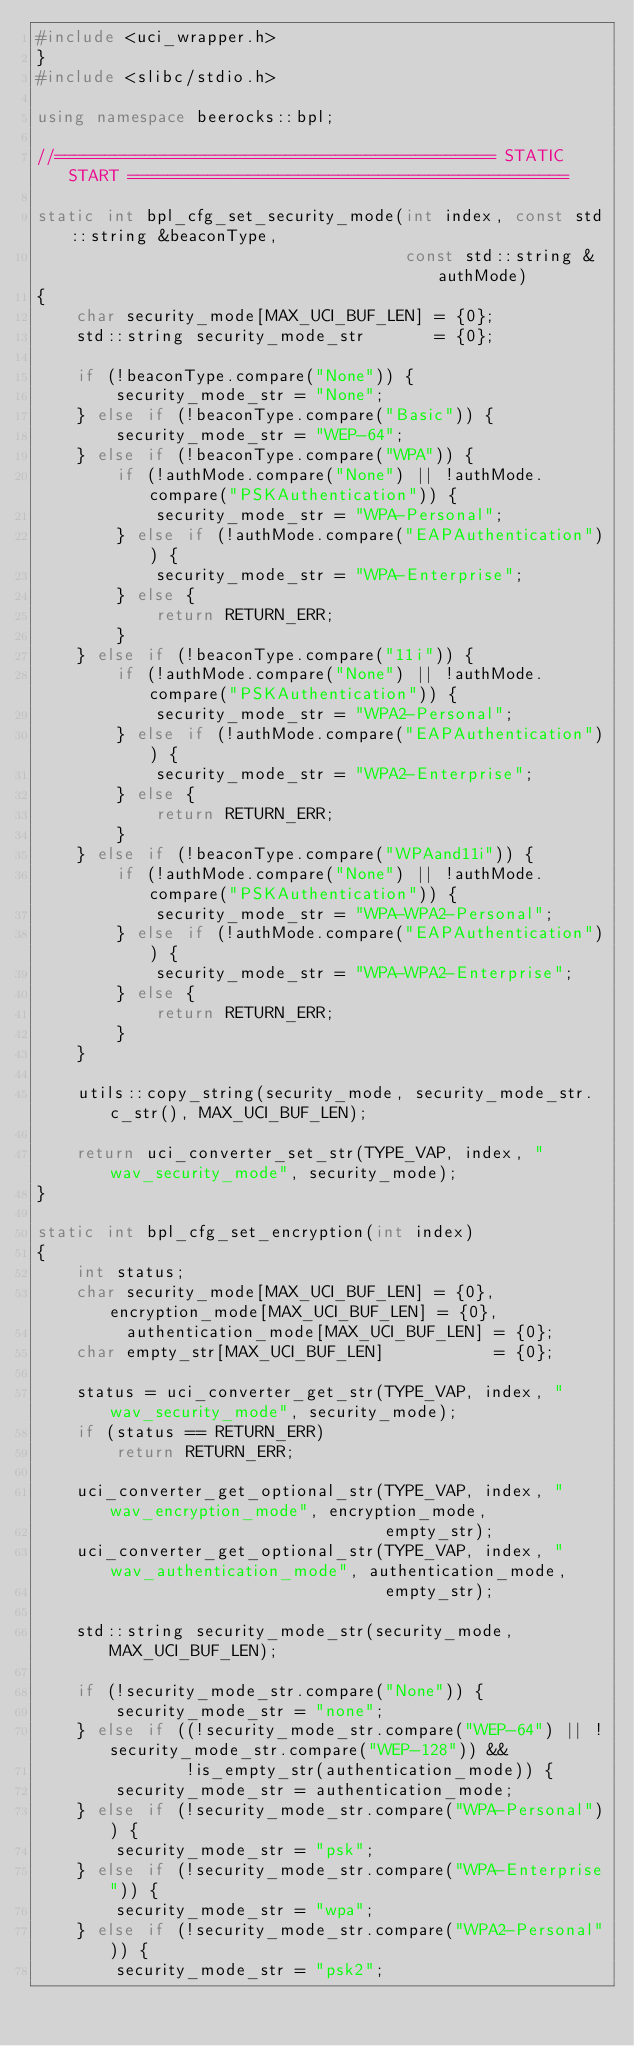Convert code to text. <code><loc_0><loc_0><loc_500><loc_500><_C++_>#include <uci_wrapper.h>
}
#include <slibc/stdio.h>

using namespace beerocks::bpl;

//============================================ STATIC START ============================================

static int bpl_cfg_set_security_mode(int index, const std::string &beaconType,
                                     const std::string &authMode)
{
    char security_mode[MAX_UCI_BUF_LEN] = {0};
    std::string security_mode_str       = {0};

    if (!beaconType.compare("None")) {
        security_mode_str = "None";
    } else if (!beaconType.compare("Basic")) {
        security_mode_str = "WEP-64";
    } else if (!beaconType.compare("WPA")) {
        if (!authMode.compare("None") || !authMode.compare("PSKAuthentication")) {
            security_mode_str = "WPA-Personal";
        } else if (!authMode.compare("EAPAuthentication")) {
            security_mode_str = "WPA-Enterprise";
        } else {
            return RETURN_ERR;
        }
    } else if (!beaconType.compare("11i")) {
        if (!authMode.compare("None") || !authMode.compare("PSKAuthentication")) {
            security_mode_str = "WPA2-Personal";
        } else if (!authMode.compare("EAPAuthentication")) {
            security_mode_str = "WPA2-Enterprise";
        } else {
            return RETURN_ERR;
        }
    } else if (!beaconType.compare("WPAand11i")) {
        if (!authMode.compare("None") || !authMode.compare("PSKAuthentication")) {
            security_mode_str = "WPA-WPA2-Personal";
        } else if (!authMode.compare("EAPAuthentication")) {
            security_mode_str = "WPA-WPA2-Enterprise";
        } else {
            return RETURN_ERR;
        }
    }

    utils::copy_string(security_mode, security_mode_str.c_str(), MAX_UCI_BUF_LEN);

    return uci_converter_set_str(TYPE_VAP, index, "wav_security_mode", security_mode);
}

static int bpl_cfg_set_encryption(int index)
{
    int status;
    char security_mode[MAX_UCI_BUF_LEN] = {0}, encryption_mode[MAX_UCI_BUF_LEN] = {0},
         authentication_mode[MAX_UCI_BUF_LEN] = {0};
    char empty_str[MAX_UCI_BUF_LEN]           = {0};

    status = uci_converter_get_str(TYPE_VAP, index, "wav_security_mode", security_mode);
    if (status == RETURN_ERR)
        return RETURN_ERR;

    uci_converter_get_optional_str(TYPE_VAP, index, "wav_encryption_mode", encryption_mode,
                                   empty_str);
    uci_converter_get_optional_str(TYPE_VAP, index, "wav_authentication_mode", authentication_mode,
                                   empty_str);

    std::string security_mode_str(security_mode, MAX_UCI_BUF_LEN);

    if (!security_mode_str.compare("None")) {
        security_mode_str = "none";
    } else if ((!security_mode_str.compare("WEP-64") || !security_mode_str.compare("WEP-128")) &&
               !is_empty_str(authentication_mode)) {
        security_mode_str = authentication_mode;
    } else if (!security_mode_str.compare("WPA-Personal")) {
        security_mode_str = "psk";
    } else if (!security_mode_str.compare("WPA-Enterprise")) {
        security_mode_str = "wpa";
    } else if (!security_mode_str.compare("WPA2-Personal")) {
        security_mode_str = "psk2";</code> 